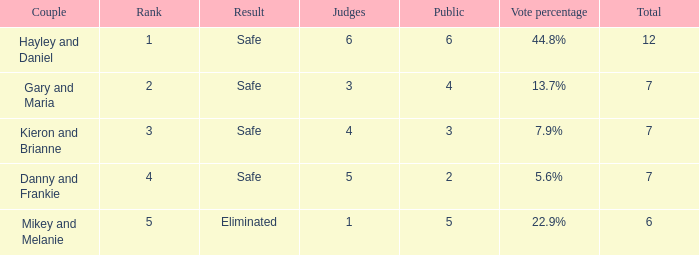How many public is there for the couple that got eliminated? 5.0. 